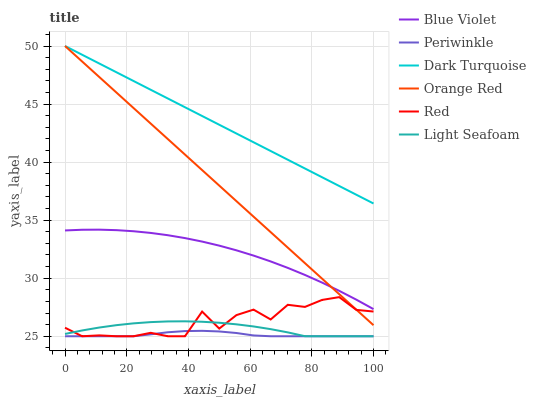Does Blue Violet have the minimum area under the curve?
Answer yes or no. No. Does Blue Violet have the maximum area under the curve?
Answer yes or no. No. Is Periwinkle the smoothest?
Answer yes or no. No. Is Periwinkle the roughest?
Answer yes or no. No. Does Blue Violet have the lowest value?
Answer yes or no. No. Does Blue Violet have the highest value?
Answer yes or no. No. Is Light Seafoam less than Dark Turquoise?
Answer yes or no. Yes. Is Dark Turquoise greater than Periwinkle?
Answer yes or no. Yes. Does Light Seafoam intersect Dark Turquoise?
Answer yes or no. No. 